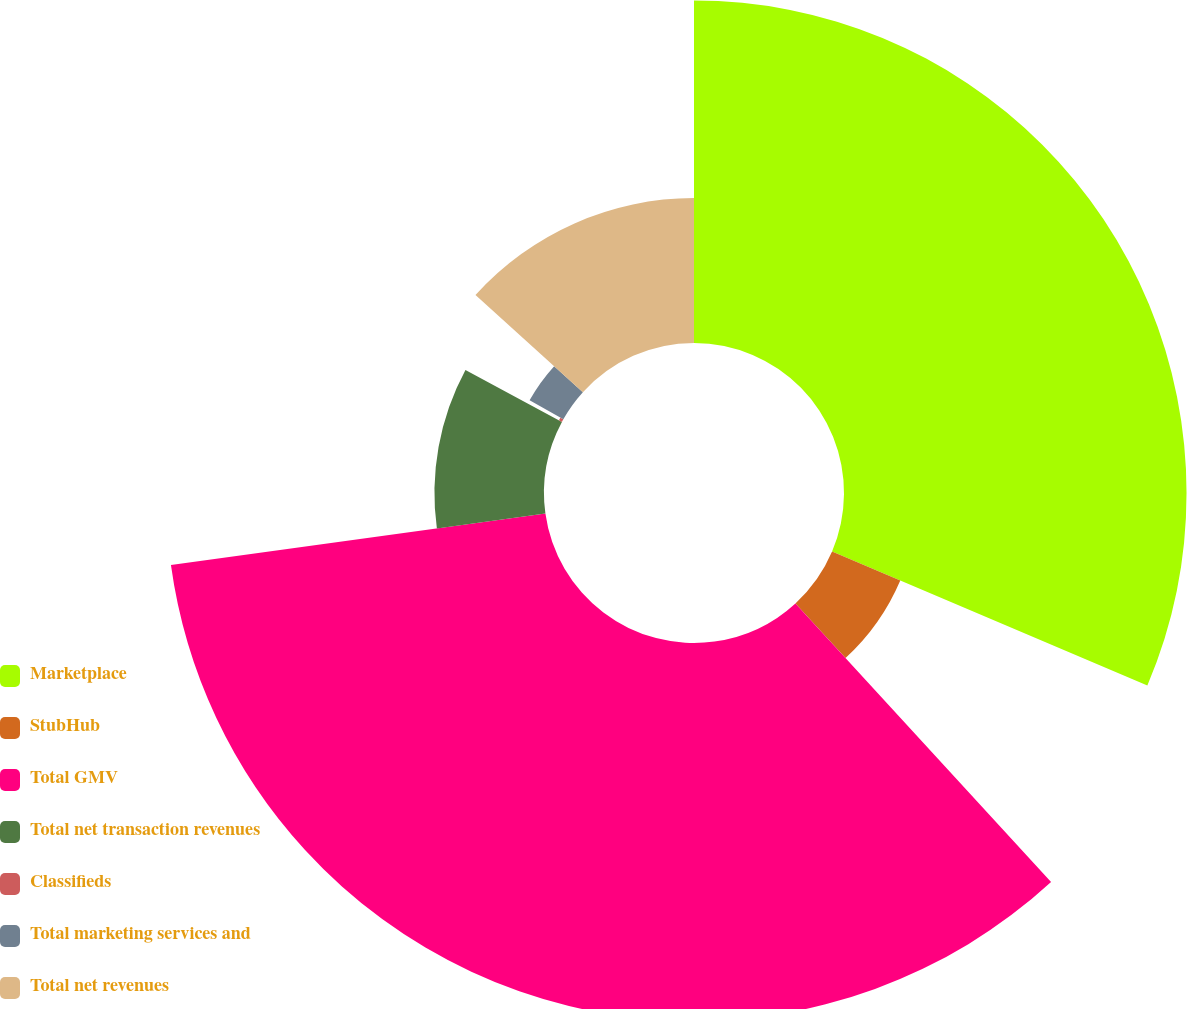Convert chart to OTSL. <chart><loc_0><loc_0><loc_500><loc_500><pie_chart><fcel>Marketplace<fcel>StubHub<fcel>Total GMV<fcel>Total net transaction revenues<fcel>Classifieds<fcel>Total marketing services and<fcel>Total net revenues<nl><fcel>31.39%<fcel>6.79%<fcel>34.64%<fcel>10.04%<fcel>0.31%<fcel>3.55%<fcel>13.28%<nl></chart> 